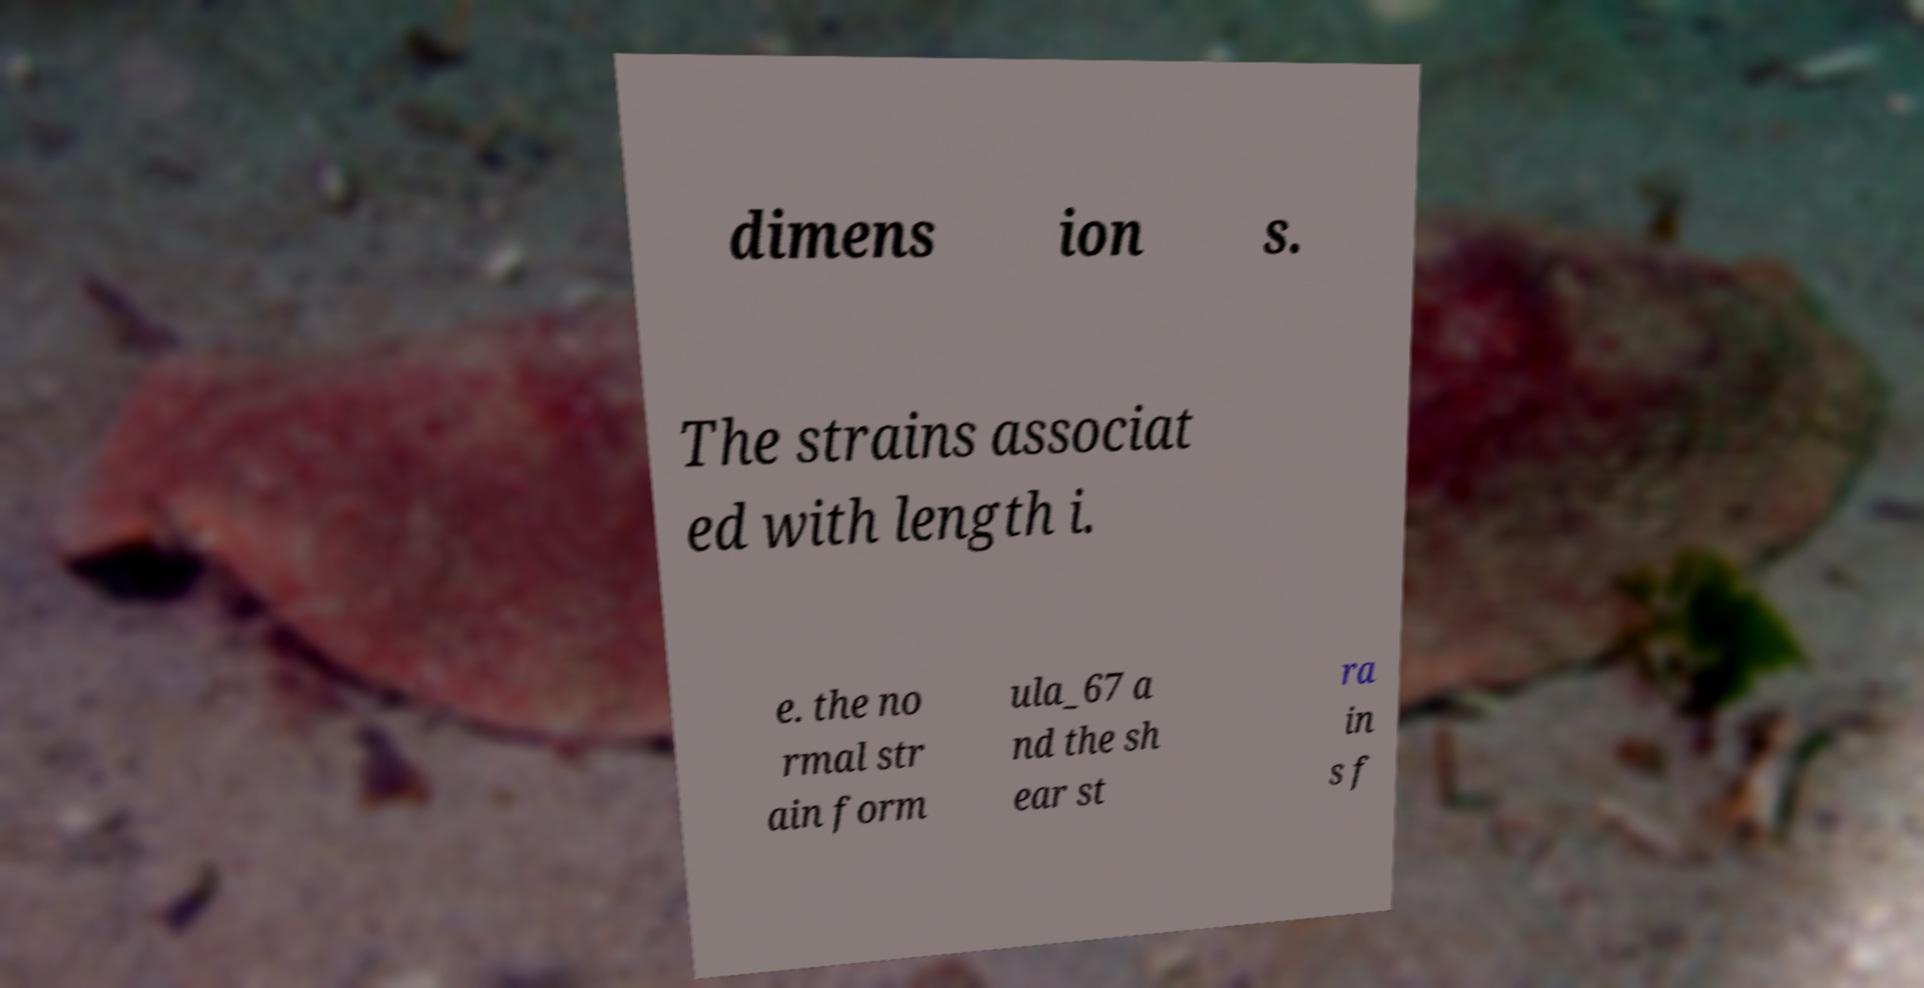I need the written content from this picture converted into text. Can you do that? dimens ion s. The strains associat ed with length i. e. the no rmal str ain form ula_67 a nd the sh ear st ra in s f 